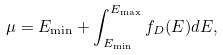Convert formula to latex. <formula><loc_0><loc_0><loc_500><loc_500>\mu = E _ { \min } + \int _ { E _ { \min } } ^ { E _ { \max } } f _ { D } ( E ) d E ,</formula> 